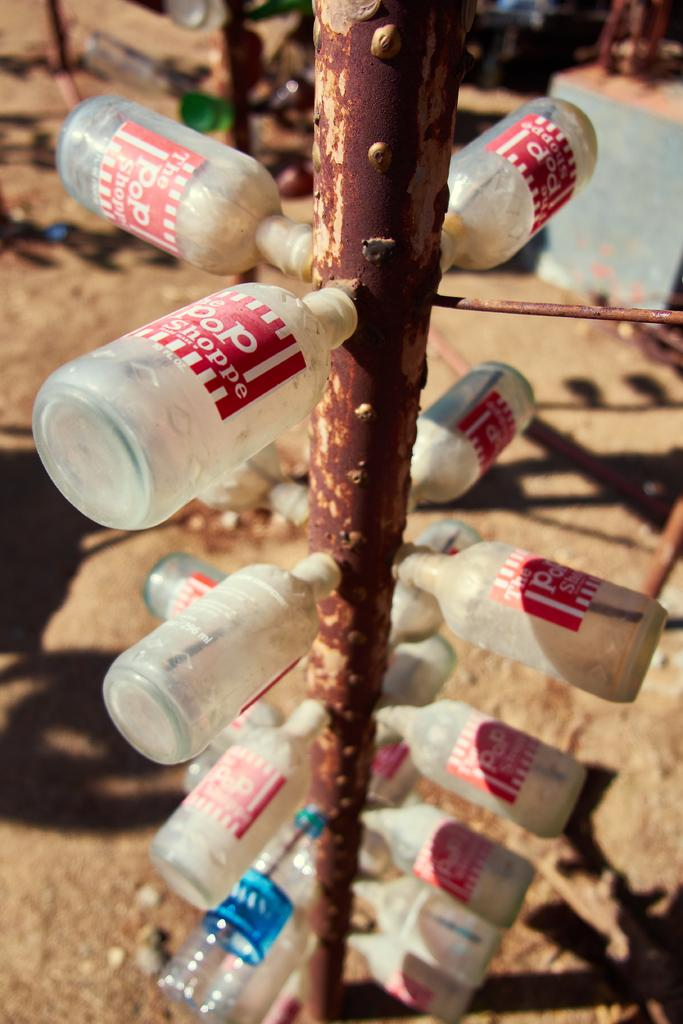What objects can be seen in the image? There are bottles in the image. How are the bottles arranged or positioned? The bottles are attached to a pole. What type of sack is being used to carry the bottles in the image? There is no sack present in the image; the bottles are attached to a pole. Is the queen visible in the image, and if so, what is she doing? There is no queen present in the image. 